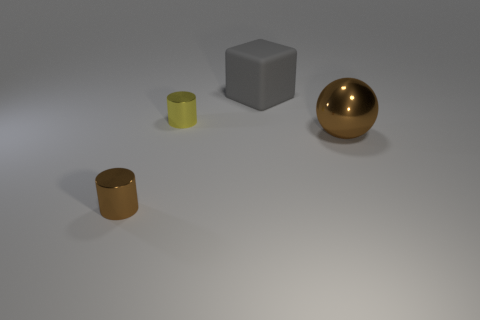Add 1 small shiny blocks. How many objects exist? 5 Subtract all cubes. How many objects are left? 3 Add 2 big things. How many big things are left? 4 Add 2 big brown things. How many big brown things exist? 3 Subtract 0 purple blocks. How many objects are left? 4 Subtract all tiny yellow things. Subtract all big spheres. How many objects are left? 2 